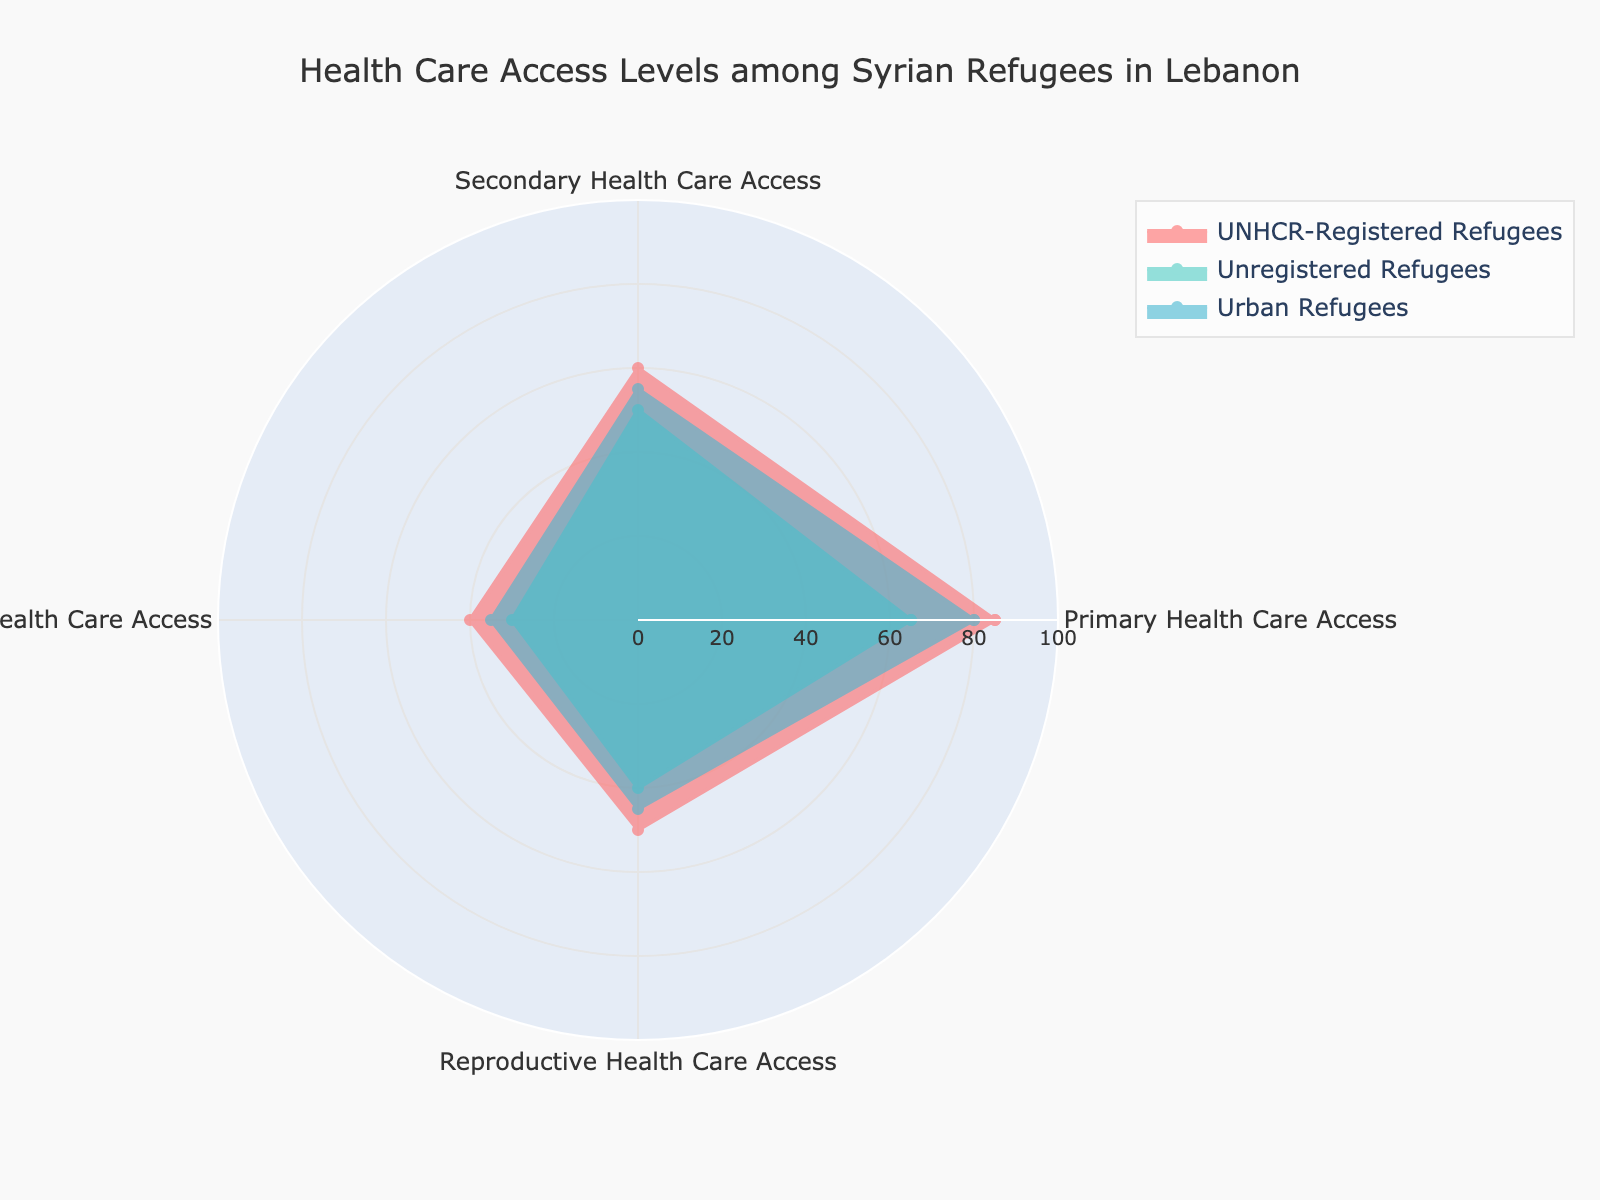What's the title of the chart? Look at the top of the chart where the title is usually placed.
Answer: Health Care Access Levels among Syrian Refugees in Lebanon How many groups are compared in the radar chart? Count the distinct groups represented in the legend of the chart.
Answer: 3 Which group has the highest access to Primary Health Care? Compare the values for Primary Health Care access among the three groups.
Answer: UNHCR-Registered Refugees Which type of health care do Urban Refugees have the least access to? Examine the values corresponding to Urban Refugees and identify the minimum value across the four types of health care.
Answer: Mental Health Care Access How does access to Reproductive Health Care compare between Urban Refugees and Unregistered Refugees? Look at the values for Reproductive Health Care access for both groups and compare them.
Answer: Urban Refugees have a slightly higher access (45 vs. 40) What's the difference in access to Secondary Health Care between UNHCR-Registered Refugees and Unregistered Refugees? Subtract the value of Secondary Health Care access for Unregistered Refugees from that of UNHCR-Registered Refugees.
Answer: 10 Among the displayed groups, which health care type has the largest range of access levels? Calculate the range for each type of health care by finding the difference between the maximum and minimum values of access levels.
Answer: Primary Health Care Access (20) Which group has the most balanced (least variation) access levels across all health care types? Compare the range of access levels within each group. The group with the smallest range has the most balanced access levels.
Answer: Urban Refugees Rank the groups by their access to Mental Health Care, from highest to lowest. Compare the values for Mental Health Care access across the three groups and order them accordingly.
Answer: UNHCR-Registered Refugees, Urban Refugees, Unregistered Refugees Is there any type of health care where all three groups have equal access? Check if any of the values for a particular health care type are the same across all groups.
Answer: No 